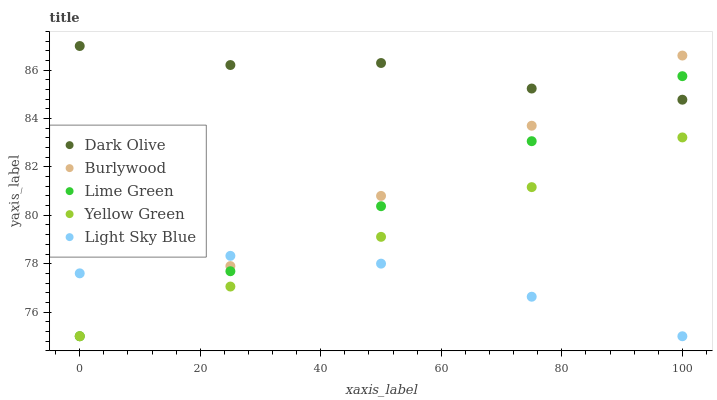Does Light Sky Blue have the minimum area under the curve?
Answer yes or no. Yes. Does Dark Olive have the maximum area under the curve?
Answer yes or no. Yes. Does Lime Green have the minimum area under the curve?
Answer yes or no. No. Does Lime Green have the maximum area under the curve?
Answer yes or no. No. Is Lime Green the smoothest?
Answer yes or no. Yes. Is Dark Olive the roughest?
Answer yes or no. Yes. Is Dark Olive the smoothest?
Answer yes or no. No. Is Lime Green the roughest?
Answer yes or no. No. Does Burlywood have the lowest value?
Answer yes or no. Yes. Does Dark Olive have the lowest value?
Answer yes or no. No. Does Dark Olive have the highest value?
Answer yes or no. Yes. Does Lime Green have the highest value?
Answer yes or no. No. Is Yellow Green less than Dark Olive?
Answer yes or no. Yes. Is Dark Olive greater than Yellow Green?
Answer yes or no. Yes. Does Burlywood intersect Dark Olive?
Answer yes or no. Yes. Is Burlywood less than Dark Olive?
Answer yes or no. No. Is Burlywood greater than Dark Olive?
Answer yes or no. No. Does Yellow Green intersect Dark Olive?
Answer yes or no. No. 